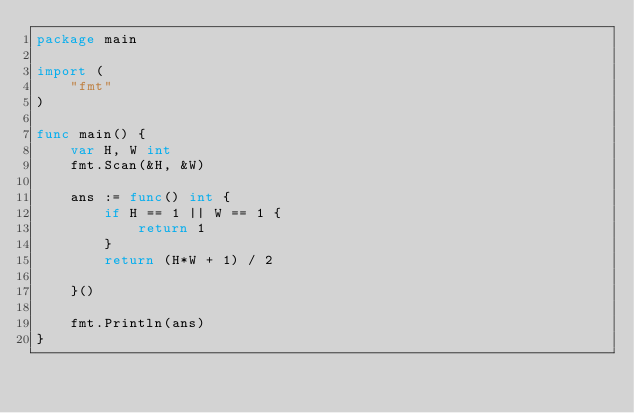<code> <loc_0><loc_0><loc_500><loc_500><_Go_>package main

import (
	"fmt"
)

func main() {
	var H, W int
	fmt.Scan(&H, &W)

	ans := func() int {
		if H == 1 || W == 1 {
			return 1
		}
		return (H*W + 1) / 2

	}()

	fmt.Println(ans)
}
</code> 